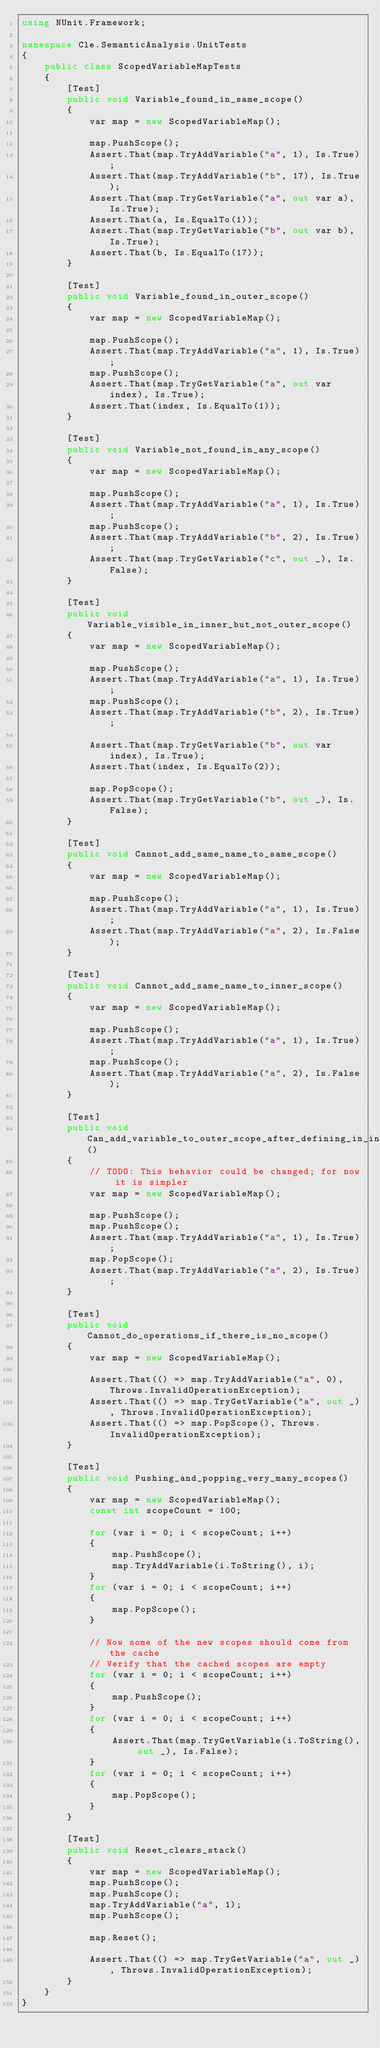Convert code to text. <code><loc_0><loc_0><loc_500><loc_500><_C#_>using NUnit.Framework;

namespace Cle.SemanticAnalysis.UnitTests
{
    public class ScopedVariableMapTests
    {
        [Test]
        public void Variable_found_in_same_scope()
        {
            var map = new ScopedVariableMap();
            
            map.PushScope();
            Assert.That(map.TryAddVariable("a", 1), Is.True);
            Assert.That(map.TryAddVariable("b", 17), Is.True);
            Assert.That(map.TryGetVariable("a", out var a), Is.True);
            Assert.That(a, Is.EqualTo(1));
            Assert.That(map.TryGetVariable("b", out var b), Is.True);
            Assert.That(b, Is.EqualTo(17));
        }

        [Test]
        public void Variable_found_in_outer_scope()
        {
            var map = new ScopedVariableMap();
            
            map.PushScope();
            Assert.That(map.TryAddVariable("a", 1), Is.True);
            map.PushScope();
            Assert.That(map.TryGetVariable("a", out var index), Is.True);
            Assert.That(index, Is.EqualTo(1));
        }

        [Test]
        public void Variable_not_found_in_any_scope()
        {
            var map = new ScopedVariableMap();
            
            map.PushScope();
            Assert.That(map.TryAddVariable("a", 1), Is.True);
            map.PushScope();
            Assert.That(map.TryAddVariable("b", 2), Is.True);
            Assert.That(map.TryGetVariable("c", out _), Is.False);
        }

        [Test]
        public void Variable_visible_in_inner_but_not_outer_scope()
        {
            var map = new ScopedVariableMap();
            
            map.PushScope();
            Assert.That(map.TryAddVariable("a", 1), Is.True);
            map.PushScope();
            Assert.That(map.TryAddVariable("b", 2), Is.True);

            Assert.That(map.TryGetVariable("b", out var index), Is.True);
            Assert.That(index, Is.EqualTo(2));

            map.PopScope();
            Assert.That(map.TryGetVariable("b", out _), Is.False);
        }

        [Test]
        public void Cannot_add_same_name_to_same_scope()
        {
            var map = new ScopedVariableMap();

            map.PushScope();
            Assert.That(map.TryAddVariable("a", 1), Is.True);
            Assert.That(map.TryAddVariable("a", 2), Is.False);
        }

        [Test]
        public void Cannot_add_same_name_to_inner_scope()
        {
            var map = new ScopedVariableMap();

            map.PushScope();
            Assert.That(map.TryAddVariable("a", 1), Is.True);
            map.PushScope();
            Assert.That(map.TryAddVariable("a", 2), Is.False);
        }

        [Test]
        public void Can_add_variable_to_outer_scope_after_defining_in_inner()
        {
            // TODO: This behavior could be changed; for now it is simpler
            var map = new ScopedVariableMap();

            map.PushScope();
            map.PushScope();
            Assert.That(map.TryAddVariable("a", 1), Is.True);
            map.PopScope();
            Assert.That(map.TryAddVariable("a", 2), Is.True);
        }

        [Test]
        public void Cannot_do_operations_if_there_is_no_scope()
        {
            var map = new ScopedVariableMap();

            Assert.That(() => map.TryAddVariable("a", 0), Throws.InvalidOperationException);
            Assert.That(() => map.TryGetVariable("a", out _), Throws.InvalidOperationException);
            Assert.That(() => map.PopScope(), Throws.InvalidOperationException);
        }

        [Test]
        public void Pushing_and_popping_very_many_scopes()
        {
            var map = new ScopedVariableMap();
            const int scopeCount = 100;

            for (var i = 0; i < scopeCount; i++)
            {
                map.PushScope();
                map.TryAddVariable(i.ToString(), i);
            }
            for (var i = 0; i < scopeCount; i++)
            {
                map.PopScope();
            }

            // Now some of the new scopes should come from the cache
            // Verify that the cached scopes are empty
            for (var i = 0; i < scopeCount; i++)
            {
                map.PushScope();
            }
            for (var i = 0; i < scopeCount; i++)
            {
                Assert.That(map.TryGetVariable(i.ToString(), out _), Is.False);
            }
            for (var i = 0; i < scopeCount; i++)
            {
                map.PopScope();
            }
        }

        [Test]
        public void Reset_clears_stack()
        {
            var map = new ScopedVariableMap();
            map.PushScope();
            map.PushScope();
            map.TryAddVariable("a", 1);
            map.PushScope();

            map.Reset();

            Assert.That(() => map.TryGetVariable("a", out _), Throws.InvalidOperationException);
        }
    }
}
</code> 